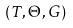<formula> <loc_0><loc_0><loc_500><loc_500>( T , \Theta , G )</formula> 